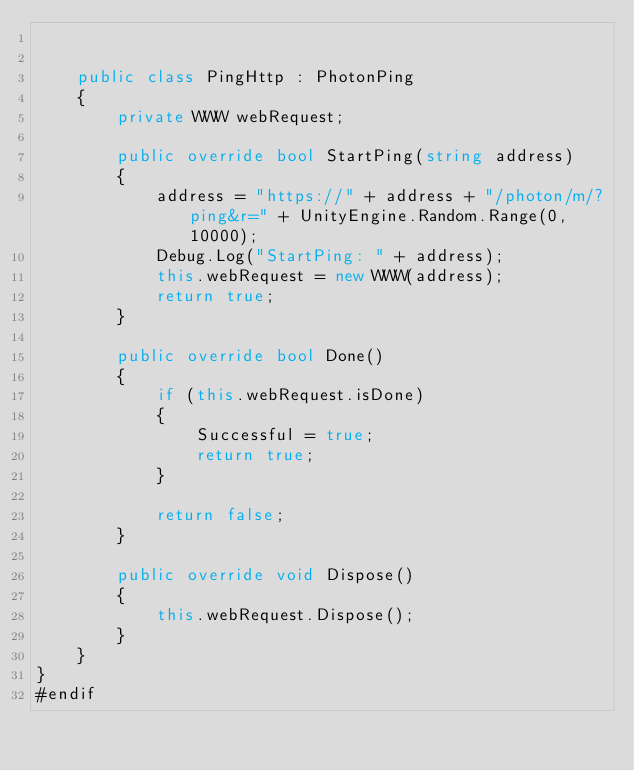Convert code to text. <code><loc_0><loc_0><loc_500><loc_500><_C#_>

    public class PingHttp : PhotonPing
    {
        private WWW webRequest;

        public override bool StartPing(string address)
        {
            address = "https://" + address + "/photon/m/?ping&r=" + UnityEngine.Random.Range(0, 10000);
            Debug.Log("StartPing: " + address);
            this.webRequest = new WWW(address);
            return true;
        }

        public override bool Done()
        {
            if (this.webRequest.isDone)
            {
                Successful = true;
                return true;
            }

            return false;
        }

        public override void Dispose()
        {
            this.webRequest.Dispose();
        }
    }
}
#endif
</code> 